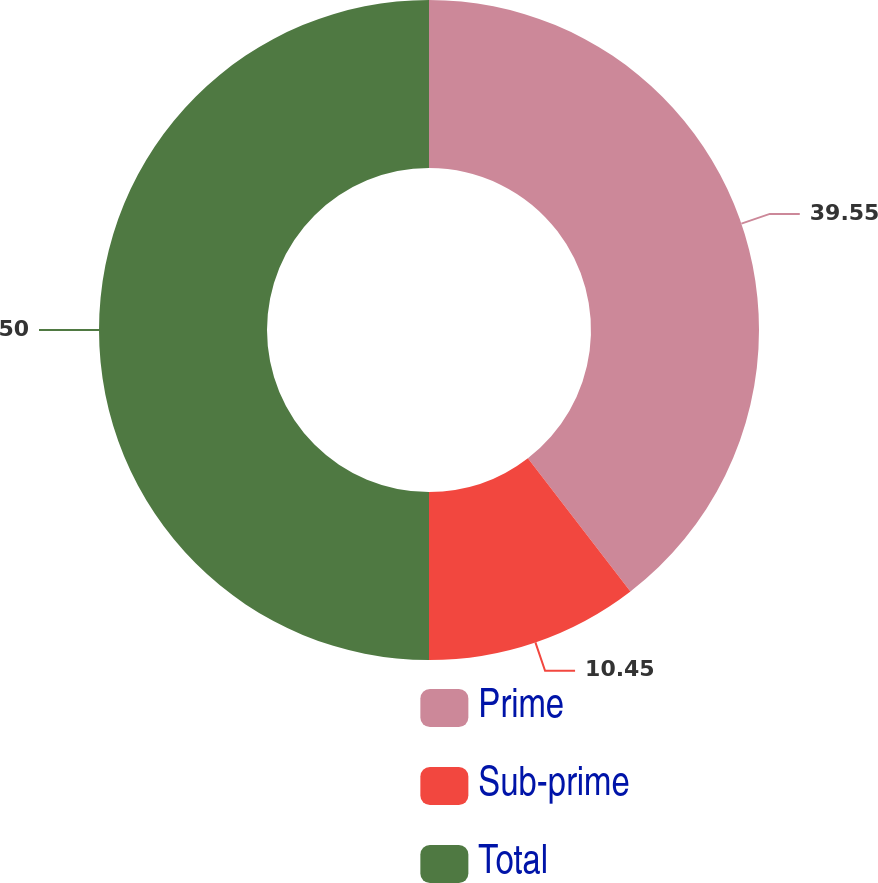Convert chart to OTSL. <chart><loc_0><loc_0><loc_500><loc_500><pie_chart><fcel>Prime<fcel>Sub-prime<fcel>Total<nl><fcel>39.55%<fcel>10.45%<fcel>50.0%<nl></chart> 